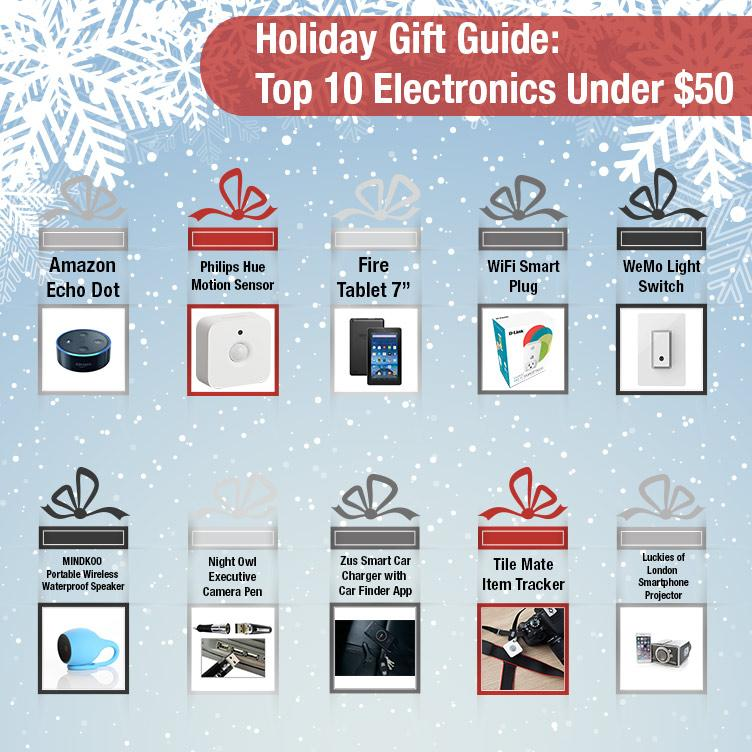Specify some key components in this picture. The product showcased in a black gift package is the WeMo Light Switch. The motion sensor and item tracker products are showcased within a red gift wrap. The sensing device shown in the image is Philips. 